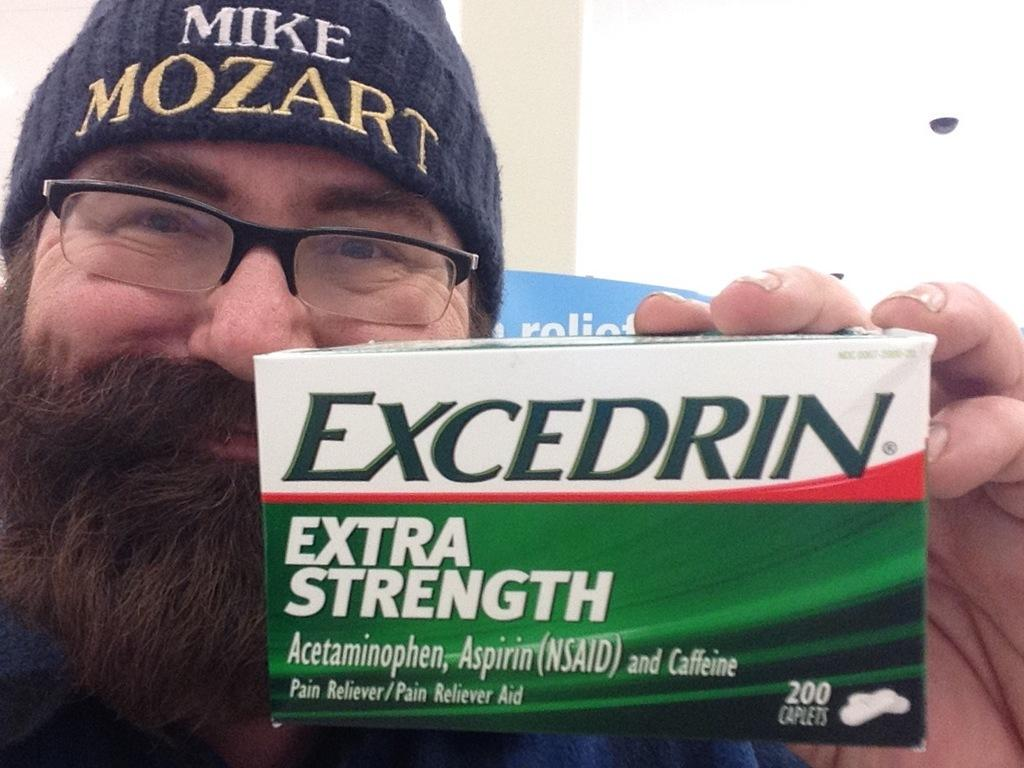What can be seen in the image? There is a person in the image. Can you describe the person's attire? The person is wearing a blue cap. What is the person holding in their hand? The person is holding a tablet box in their hand. What type of thread is being used to sew the person's cap in the image? There is no thread visible in the image, as the person is wearing a blue cap that is already made. 